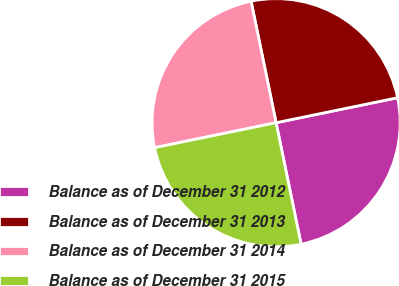Convert chart to OTSL. <chart><loc_0><loc_0><loc_500><loc_500><pie_chart><fcel>Balance as of December 31 2012<fcel>Balance as of December 31 2013<fcel>Balance as of December 31 2014<fcel>Balance as of December 31 2015<nl><fcel>25.0%<fcel>25.0%<fcel>25.0%<fcel>25.0%<nl></chart> 